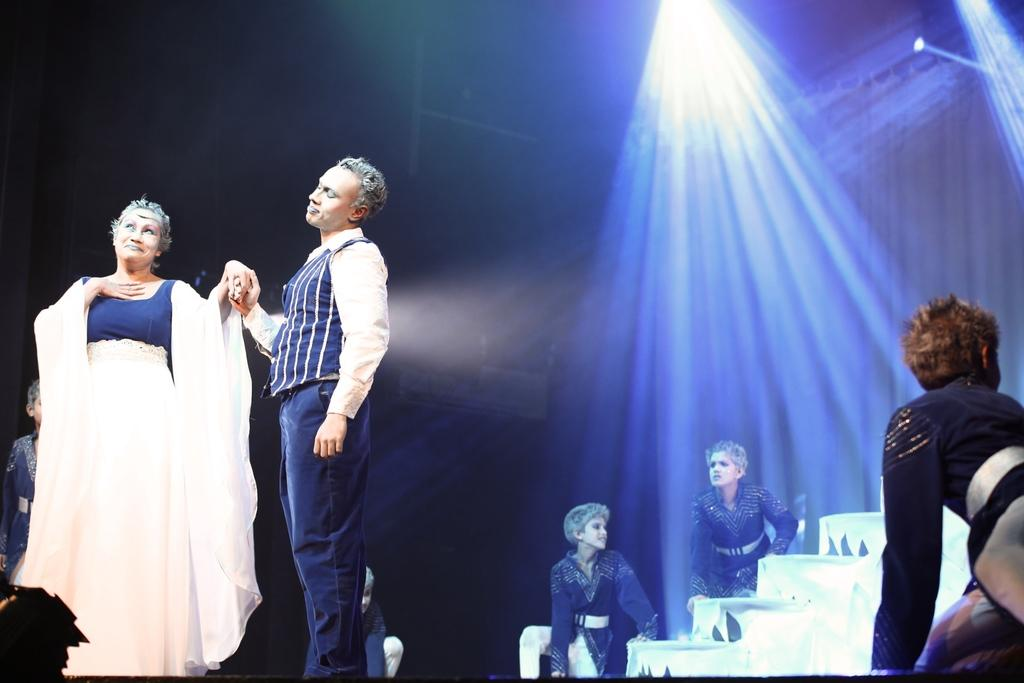How many people are standing on the left side of the image? There are two persons standing on the left side of the image. What is one of the persons doing? One of the persons is dancing. Can you describe the background of the image? There are some persons in the background of the image. What can be seen at the top of the image? There are lights arranged at the top of the image. What type of pollution can be seen in the image? There is no pollution visible in the image. Can you tell me how many dolls are present in the image? There are no dolls present in the image. 